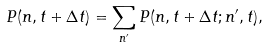<formula> <loc_0><loc_0><loc_500><loc_500>P ( n , t + \Delta t ) = \sum _ { n ^ { \prime } } P ( n , t + \Delta t ; n ^ { \prime } , t ) ,</formula> 